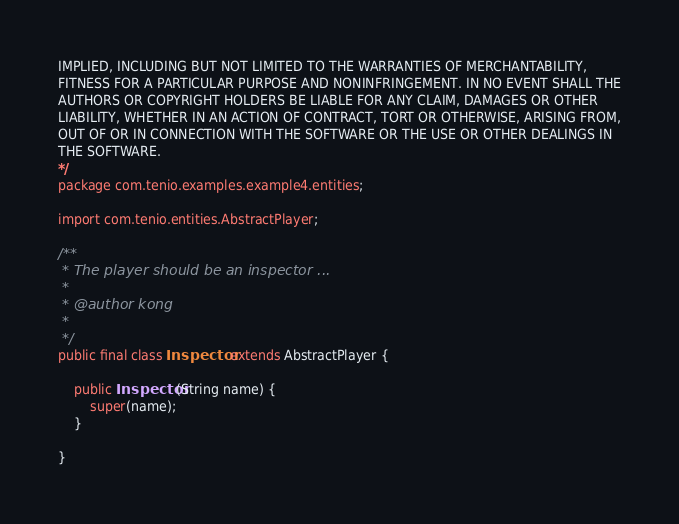<code> <loc_0><loc_0><loc_500><loc_500><_Java_>IMPLIED, INCLUDING BUT NOT LIMITED TO THE WARRANTIES OF MERCHANTABILITY,
FITNESS FOR A PARTICULAR PURPOSE AND NONINFRINGEMENT. IN NO EVENT SHALL THE
AUTHORS OR COPYRIGHT HOLDERS BE LIABLE FOR ANY CLAIM, DAMAGES OR OTHER
LIABILITY, WHETHER IN AN ACTION OF CONTRACT, TORT OR OTHERWISE, ARISING FROM,
OUT OF OR IN CONNECTION WITH THE SOFTWARE OR THE USE OR OTHER DEALINGS IN
THE SOFTWARE.
*/
package com.tenio.examples.example4.entities;

import com.tenio.entities.AbstractPlayer;

/**
 * The player should be an inspector ...
 * 
 * @author kong
 *
 */
public final class Inspector extends AbstractPlayer {

	public Inspector(String name) {
		super(name);
	}

}
</code> 